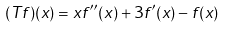<formula> <loc_0><loc_0><loc_500><loc_500>( T f ) ( x ) = x f ^ { \prime \prime } ( x ) + 3 f ^ { \prime } ( x ) - f ( x )</formula> 